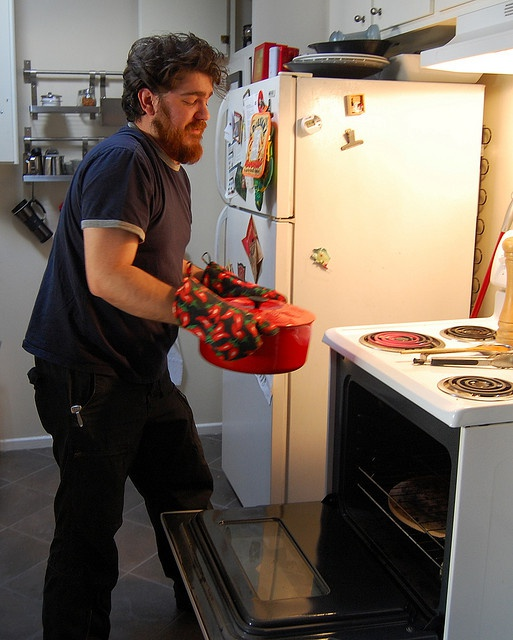Describe the objects in this image and their specific colors. I can see people in lightgray, black, maroon, and brown tones, refrigerator in lightgray, tan, beige, gray, and darkgray tones, oven in lightgray, black, maroon, and gray tones, and cup in lightgray, black, and gray tones in this image. 